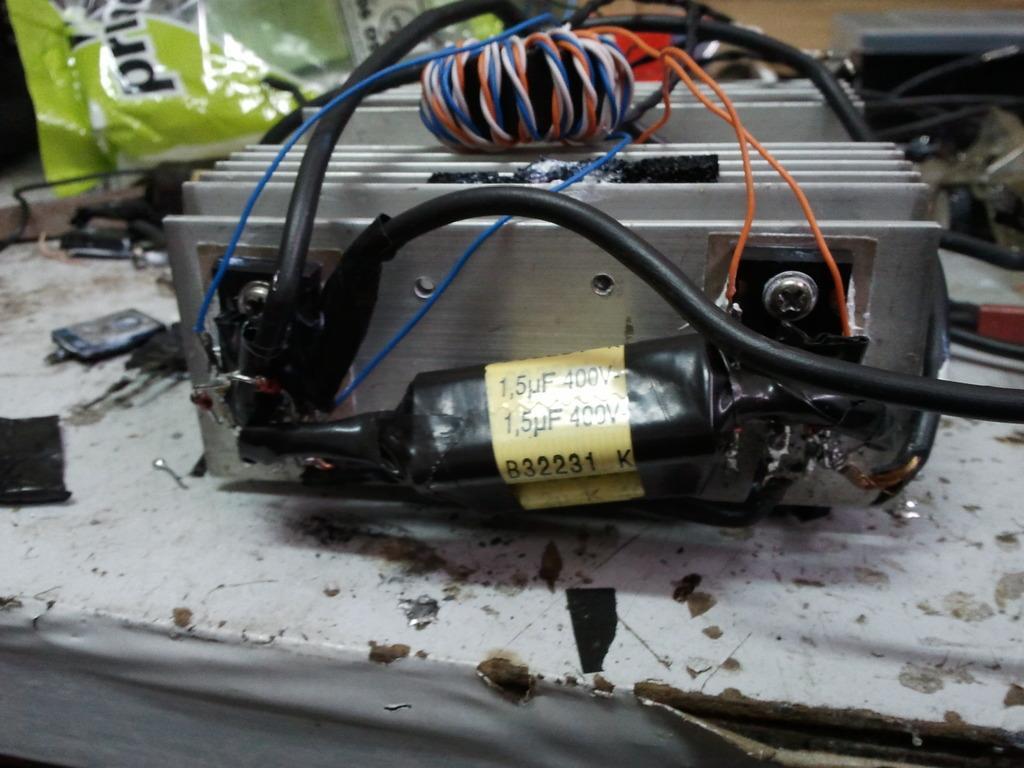How would you summarize this image in a sentence or two? In the foreground of this image, there is an electronic device with cables attached to it. In the background, there is a green colored cover and few objects. 